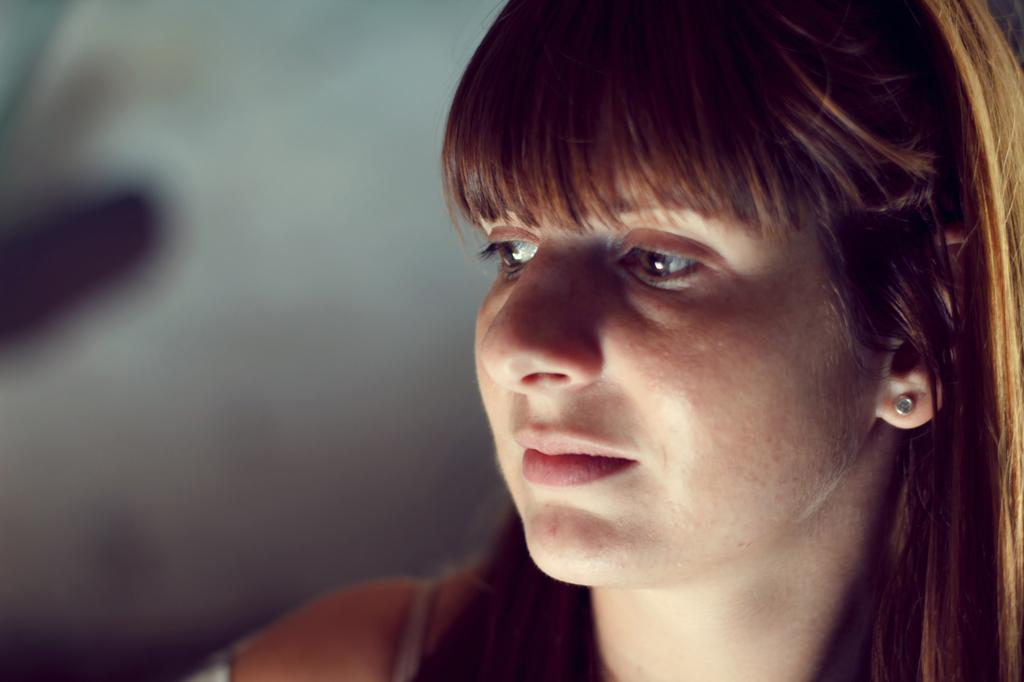Who is present on the right side of the image? There is a woman on the right side of the image. Can you describe the background of the image? The background of the image is blurry. What type of instrument is the woman playing in the image? There is no instrument present in the image, as the woman is not depicted playing any instrument. 